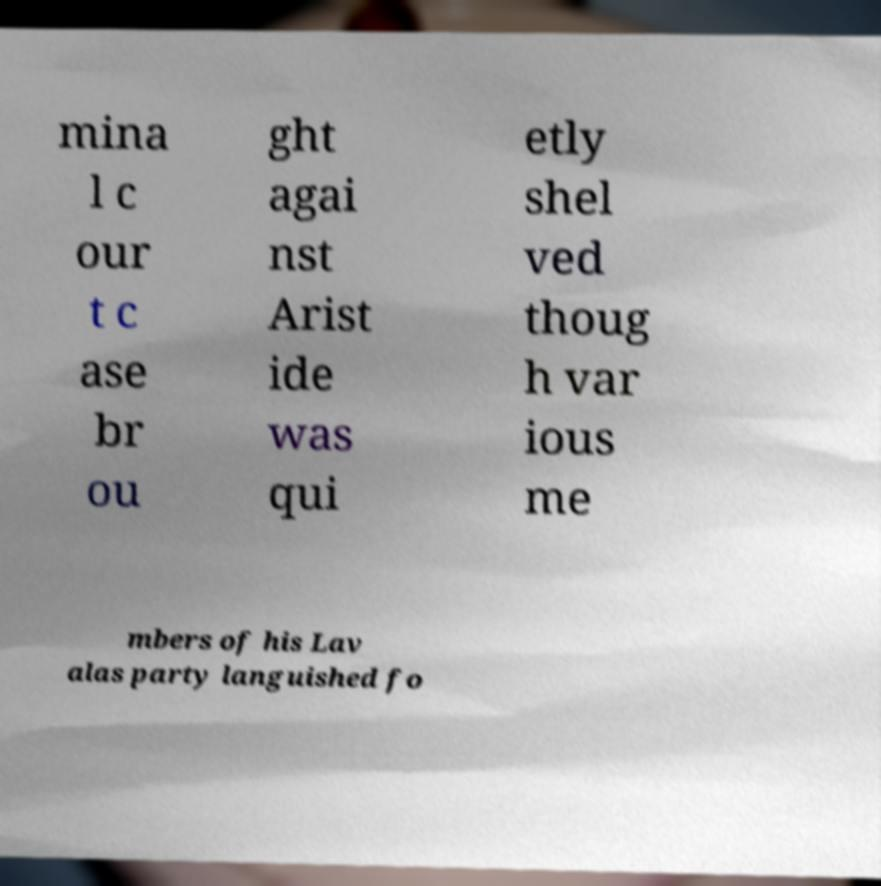Could you extract and type out the text from this image? mina l c our t c ase br ou ght agai nst Arist ide was qui etly shel ved thoug h var ious me mbers of his Lav alas party languished fo 